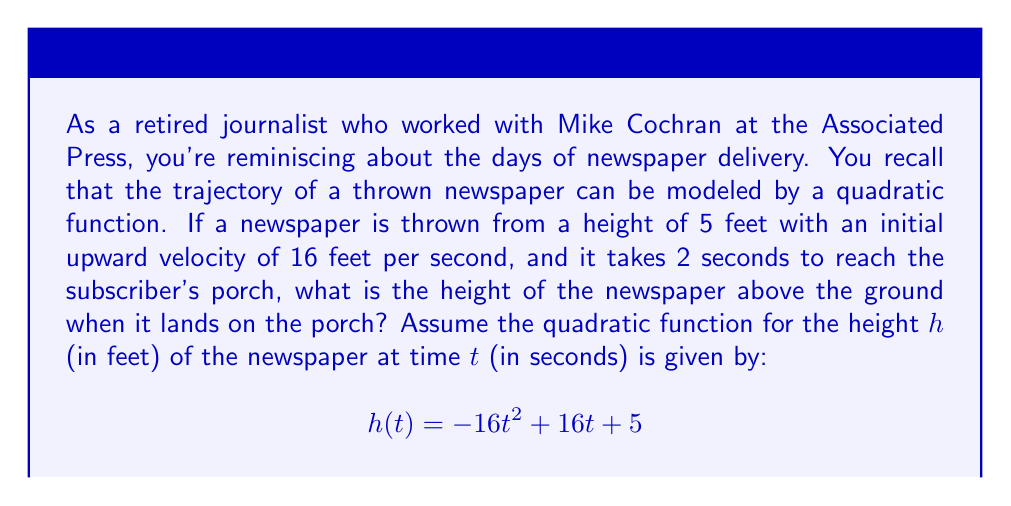Could you help me with this problem? To solve this problem, we need to follow these steps:

1) The quadratic function modeling the newspaper's trajectory is given as:
   $$h(t) = -16t^2 + 16t + 5$$

2) We're told that it takes 2 seconds for the newspaper to reach the porch. So, we need to find $h(2)$.

3) Let's substitute $t = 2$ into our function:
   $$h(2) = -16(2)^2 + 16(2) + 5$$

4) Now let's calculate step by step:
   $$h(2) = -16(4) + 32 + 5$$
   $$h(2) = -64 + 32 + 5$$
   $$h(2) = -32 + 5$$
   $$h(2) = -27$$

5) The height is negative, which doesn't make physical sense. This means the newspaper has actually hit the ground before reaching the porch.

6) To find when the newspaper hits the ground, we need to solve the equation:
   $$-16t^2 + 16t + 5 = 0$$

7) This is a quadratic equation. We can solve it using the quadratic formula:
   $$t = \frac{-b \pm \sqrt{b^2 - 4ac}}{2a}$$
   where $a = -16$, $b = 16$, and $c = 5$

8) Plugging in these values:
   $$t = \frac{-16 \pm \sqrt{16^2 - 4(-16)(5)}}{2(-16)}$$
   $$t = \frac{-16 \pm \sqrt{256 + 320}}{-32}$$
   $$t = \frac{-16 \pm \sqrt{576}}{-32}$$
   $$t = \frac{-16 \pm 24}{-32}$$

9) This gives us two solutions:
   $$t = \frac{-16 + 24}{-32} = \frac{8}{-32} = -0.25$$
   $$t = \frac{-16 - 24}{-32} = \frac{-40}{-32} = 1.25$$

10) The positive solution, 1.25 seconds, is the time when the newspaper hits the ground.
Answer: The newspaper hits the ground after approximately 1.25 seconds, before reaching the porch. At 2 seconds, when it would have reached the porch, the newspaper is actually below ground level (which isn't physically possible). The height of the newspaper when it lands is 0 feet above the ground. 